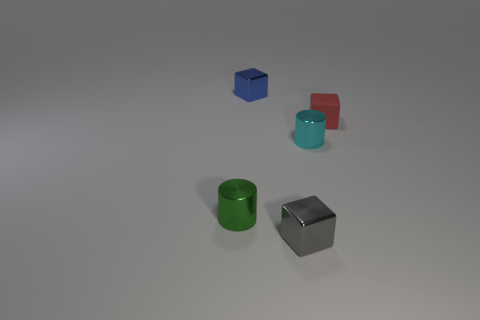Add 5 small red metal balls. How many objects exist? 10 Subtract all cubes. How many objects are left? 2 Subtract 0 cyan blocks. How many objects are left? 5 Subtract all tiny matte cylinders. Subtract all red rubber cubes. How many objects are left? 4 Add 1 small gray cubes. How many small gray cubes are left? 2 Add 4 big yellow metal cylinders. How many big yellow metal cylinders exist? 4 